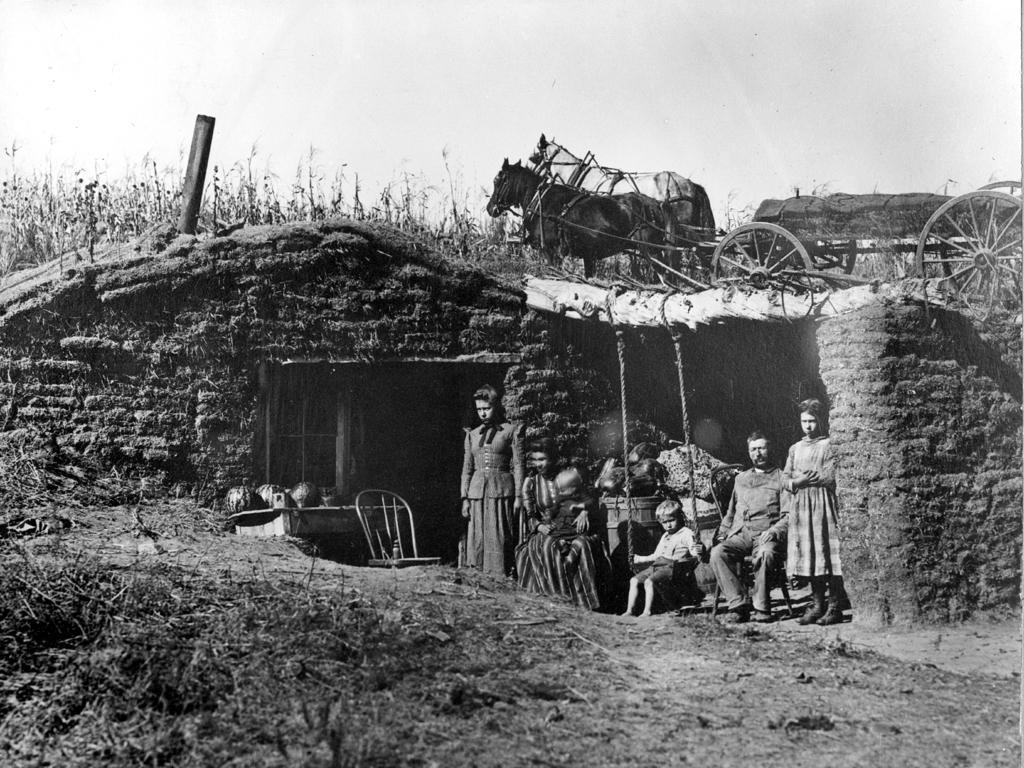In one or two sentences, can you explain what this image depicts? It is a black and white image, there is a small house constructed with sand and some people wear sitting and standing outside the house, there is a horse cart above the house and in front of the horses there are many plants. 